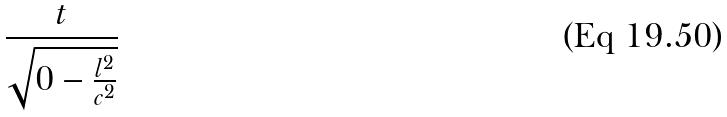Convert formula to latex. <formula><loc_0><loc_0><loc_500><loc_500>\frac { t } { \sqrt { 0 - \frac { l ^ { 2 } } { c ^ { 2 } } } }</formula> 